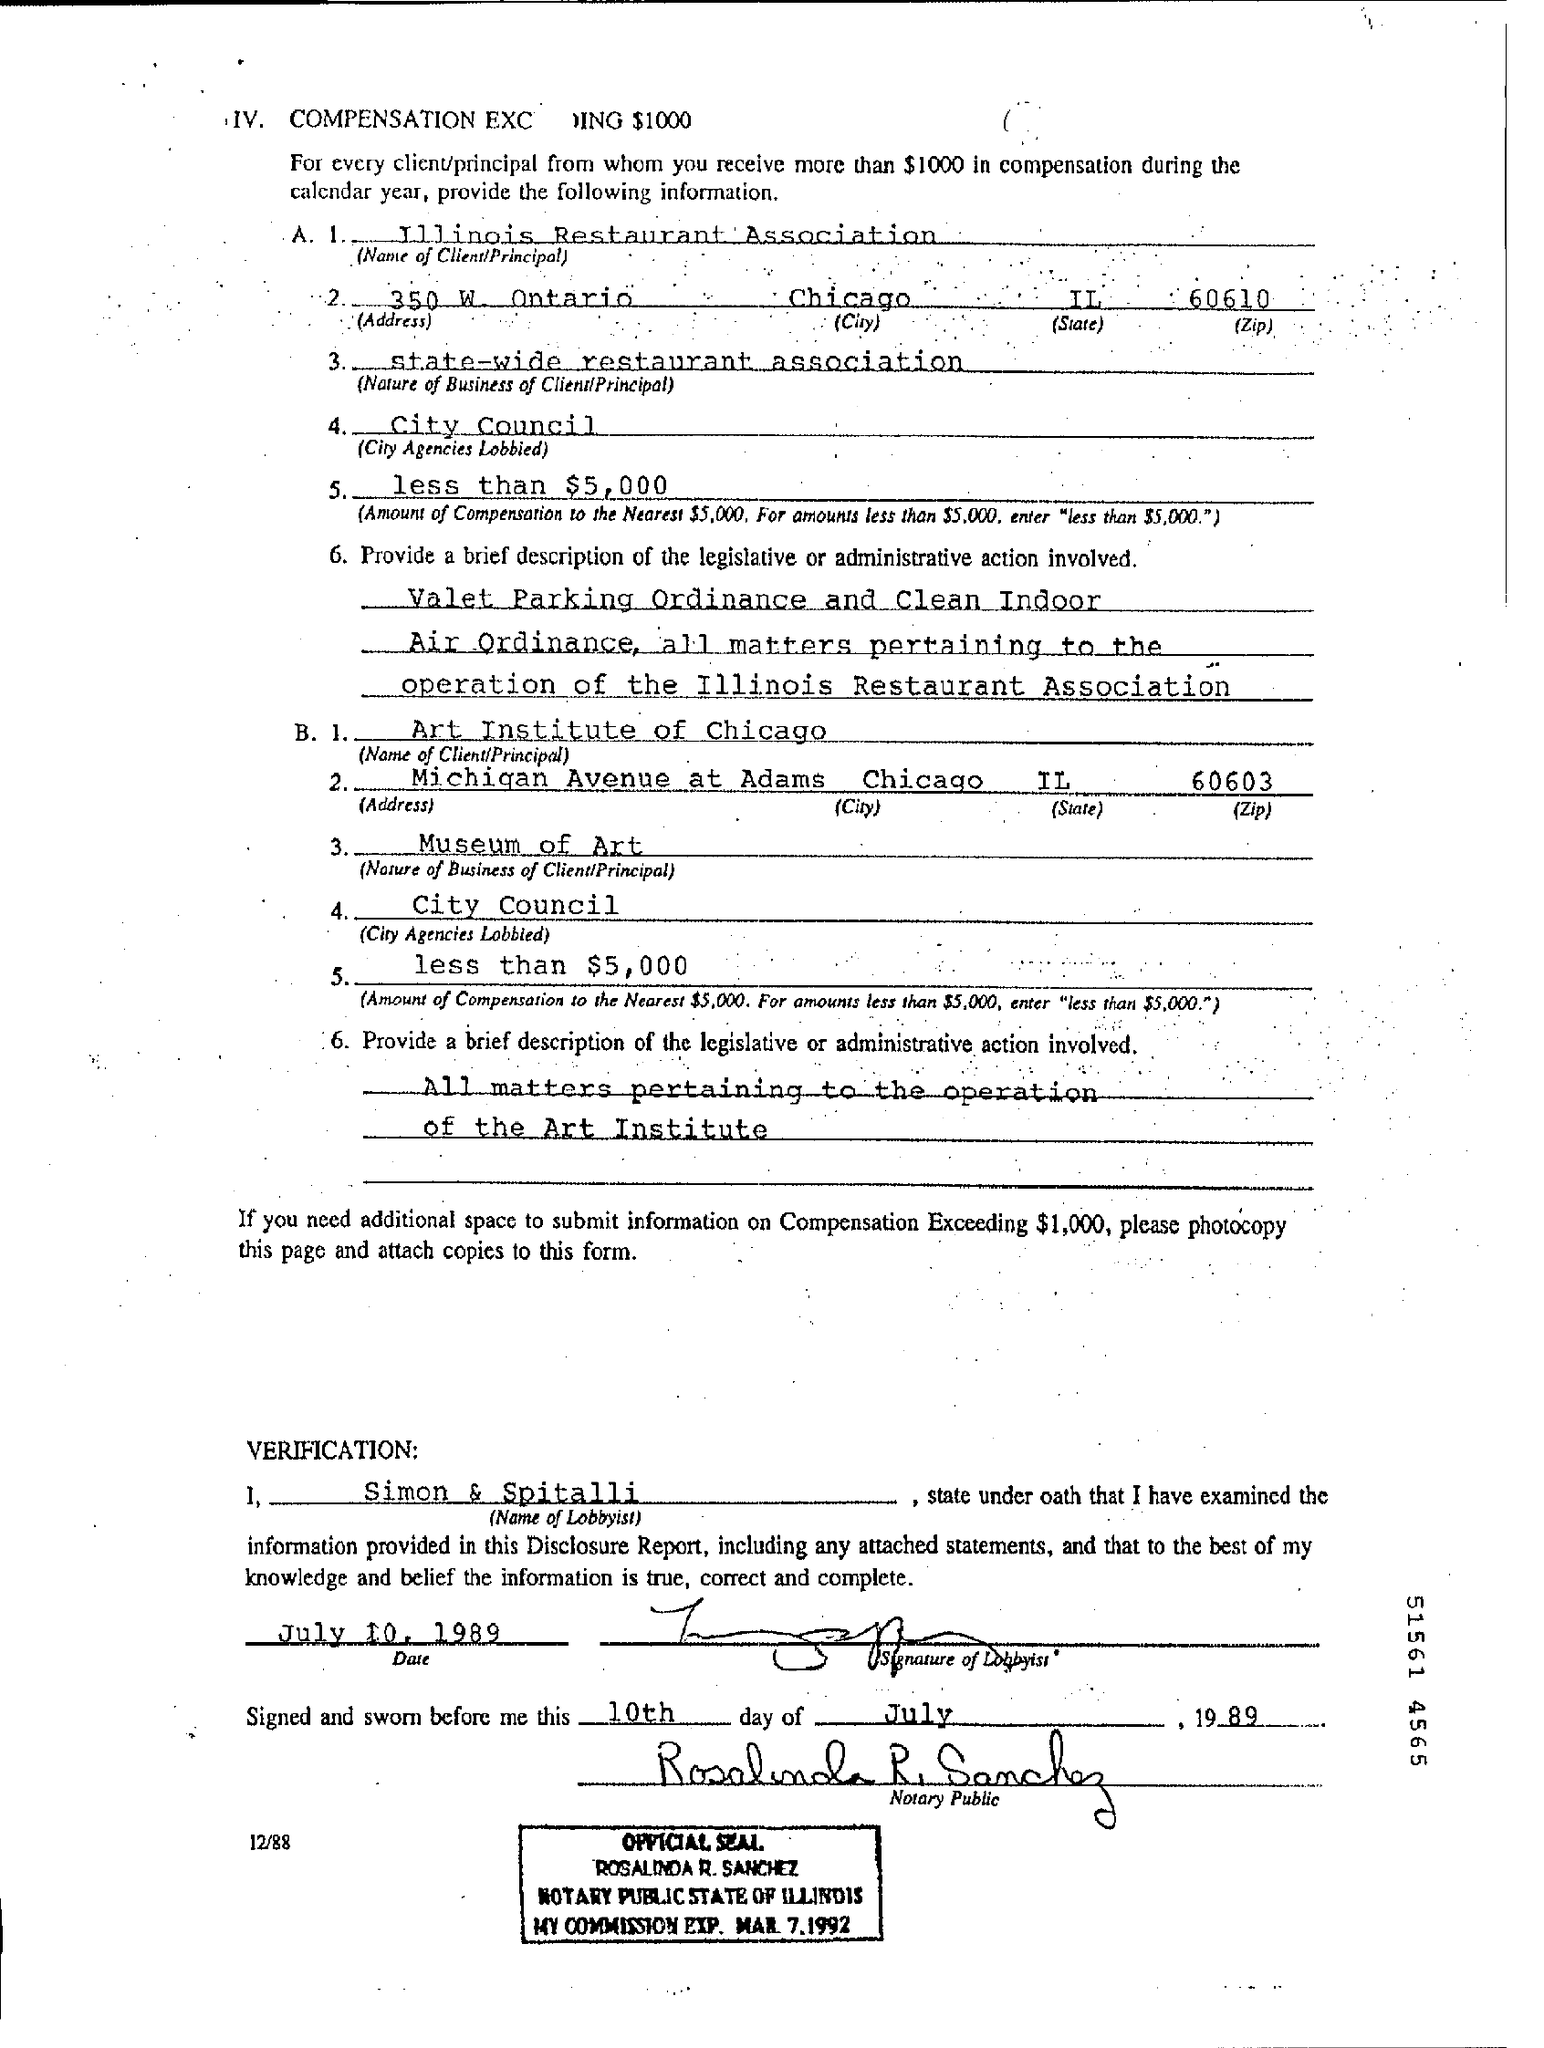Draw attention to some important aspects in this diagram. The date of verification is July 10, 1989. 